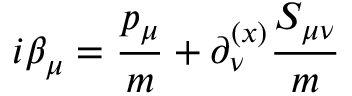<formula> <loc_0><loc_0><loc_500><loc_500>i \beta _ { \mu } = { \frac { p _ { \mu } } { m } } + \partial _ { \nu } ^ { ( x ) } { { \frac { S _ { \mu \nu } } { m } } }</formula> 